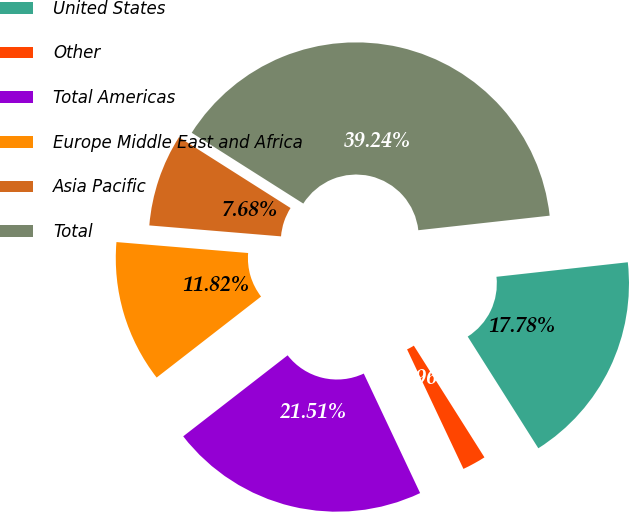Convert chart to OTSL. <chart><loc_0><loc_0><loc_500><loc_500><pie_chart><fcel>United States<fcel>Other<fcel>Total Americas<fcel>Europe Middle East and Africa<fcel>Asia Pacific<fcel>Total<nl><fcel>17.78%<fcel>1.96%<fcel>21.51%<fcel>11.82%<fcel>7.68%<fcel>39.24%<nl></chart> 